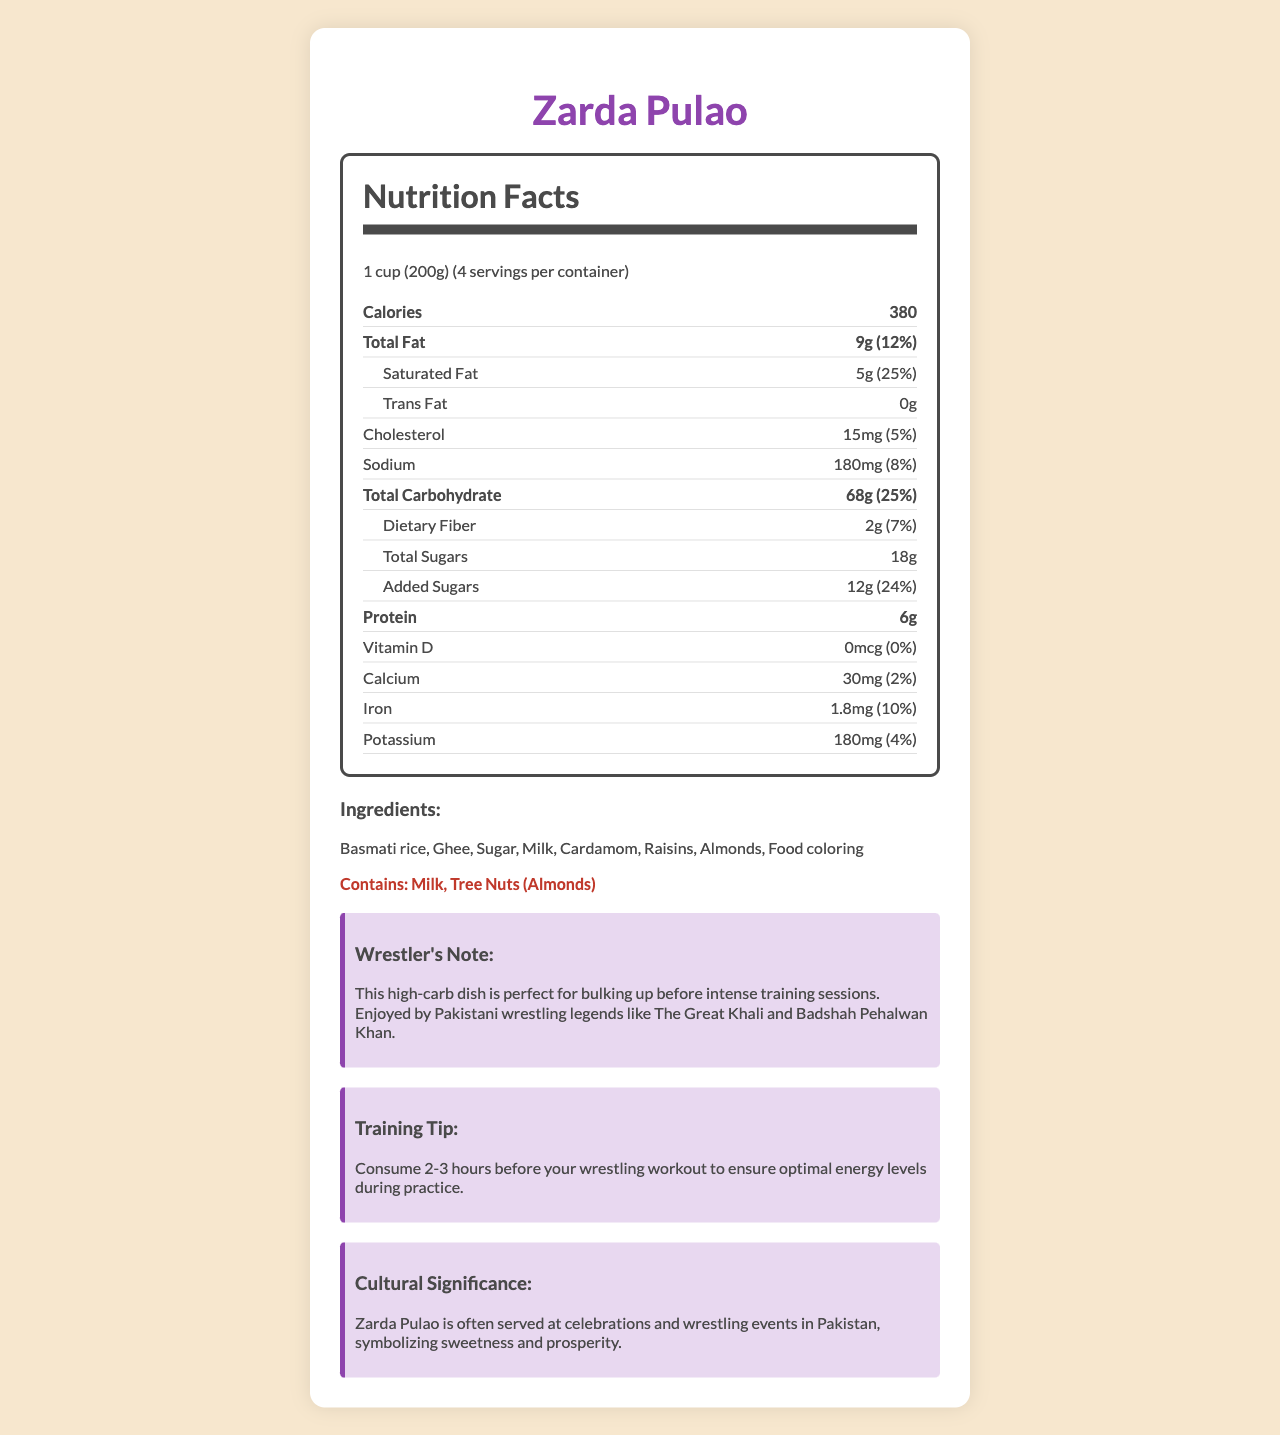what is the serving size of Zarda Pulao? The serving size is mentioned at the beginning of the nutrition facts section.
Answer: 1 cup (200g) how many servings are in one container of Zarda Pulao? The label clearly states that there are 4 servings per container.
Answer: 4 how many calories are there in one serving of Zarda Pulao? The calorie count per serving is listed in the nutrition facts.
Answer: 380 what is the total fat content in one serving? The total fat content is specified as 9 grams per serving.
Answer: 9g what percentage of the daily value is the saturated fat content? Saturated fat content is listed as 5 grams, which is 25% of the daily value.
Answer: 25% how much protein does one serving contain? The protein content per serving is indicated as 6 grams.
Answer: 6g which ingredient in Zarda Pulao serves as the primary source of carbohydrates? A. Ghee B. Sugar C. Basmati rice D. Almonds Basmati rice is the primary ingredient and the main source of carbohydrates in rice dishes.
Answer: C. Basmati rice what allergens are present in Zarda Pulao? A. Milk and Gluten B. Tree Nuts and Eggs C. Milk and Tree Nuts The allergens section clearly lists "Milk" and "Tree Nuts (Almonds)".
Answer: C. Milk and Tree Nuts does Zarda Pulao contain any vitamin D? The label shows 0 mcg of Vitamin D, which is also 0% of the daily value.
Answer: No is there any trans fat in Zarda Pulao? The nutrition facts indicate 0 grams of trans fat.
Answer: No what are the training benefits of Zarda Pulao for wrestlers? The document notes that Zarda Pulao is high-carb and perfect for bulking up before intense training sessions, recommending consuming it 2-3 hours before a workout.
Answer: High-carb, optimal energy levels summarize the nutrition facts and benefits of Zarda Pulao. The document provides an overview of the nutritional content, serving size, ingredients, allergens, benefits for wrestlers, and cultural significance of Zarda Pulao.
Answer: Zarda Pulao is a high-carb Pakistani rice dish often served at celebrations and wrestling events. It contains 380 calories per serving, with notable amounts of total fat (9g), saturated fat (5g), carbohydrates (68g), sugars (18g), and protein (6g). It provides substantial energy for training and includes ingredients such as basmati rice, ghee, and milk, along with allergenic components like milk and tree nuts (almonds). how many calories are there in the entire container of Zarda Pulao? With 4 servings per container and each serving containing 380 calories, the total would be 380 * 4 = 1520 calories.
Answer: 1520 what mineral content is higher in Zarda Pulao: Calcium or Iron? Zarda Pulao has 1.8 mg of iron (10% daily value) compared to 30 mg of calcium (2% daily value).
Answer: Iron does the document mention any gluten content? There is no mention of gluten content in the provided ingredients or allergens list.
Answer: Not enough information what is the cultural significance of Zarda Pulao in Pakistan? The document explains that Zarda Pulao is often served at celebrations and wrestling events, symbolizing sweetness and prosperity.
Answer: Symbolizes sweetness and prosperity 